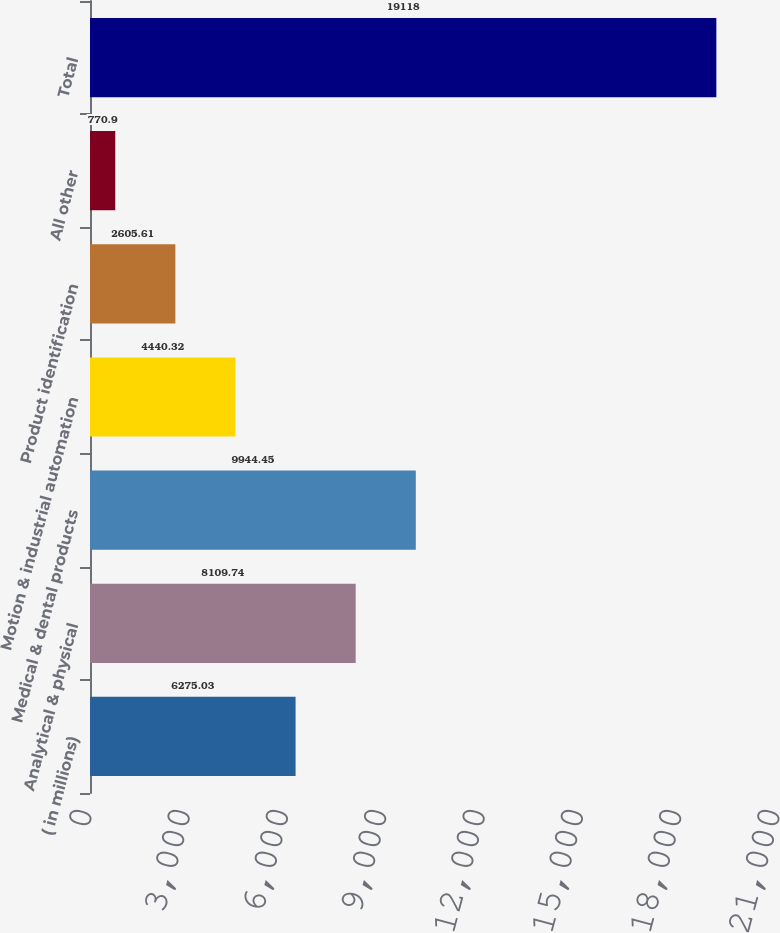<chart> <loc_0><loc_0><loc_500><loc_500><bar_chart><fcel>( in millions)<fcel>Analytical & physical<fcel>Medical & dental products<fcel>Motion & industrial automation<fcel>Product identification<fcel>All other<fcel>Total<nl><fcel>6275.03<fcel>8109.74<fcel>9944.45<fcel>4440.32<fcel>2605.61<fcel>770.9<fcel>19118<nl></chart> 